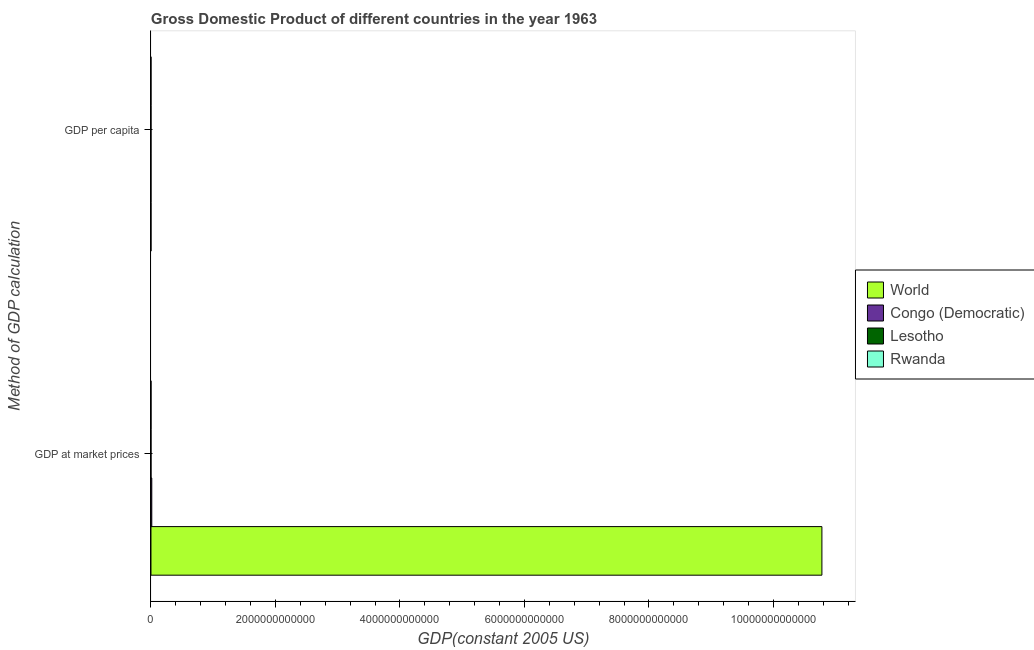Are the number of bars per tick equal to the number of legend labels?
Give a very brief answer. Yes. Are the number of bars on each tick of the Y-axis equal?
Make the answer very short. Yes. How many bars are there on the 2nd tick from the bottom?
Your response must be concise. 4. What is the label of the 1st group of bars from the top?
Ensure brevity in your answer.  GDP per capita. What is the gdp per capita in Rwanda?
Provide a succinct answer. 200.73. Across all countries, what is the maximum gdp per capita?
Ensure brevity in your answer.  3374.82. Across all countries, what is the minimum gdp per capita?
Make the answer very short. 200.73. In which country was the gdp per capita minimum?
Give a very brief answer. Rwanda. What is the total gdp per capita in the graph?
Provide a succinct answer. 4613.54. What is the difference between the gdp per capita in Congo (Democratic) and that in Rwanda?
Ensure brevity in your answer.  594.16. What is the difference between the gdp per capita in Rwanda and the gdp at market prices in Lesotho?
Your response must be concise. -2.18e+08. What is the average gdp per capita per country?
Provide a succinct answer. 1153.39. What is the difference between the gdp per capita and gdp at market prices in Lesotho?
Offer a terse response. -2.18e+08. In how many countries, is the gdp at market prices greater than 8000000000000 US$?
Your answer should be very brief. 1. What is the ratio of the gdp at market prices in Congo (Democratic) to that in Rwanda?
Make the answer very short. 21.01. Is the gdp at market prices in Lesotho less than that in Rwanda?
Offer a terse response. Yes. What does the 1st bar from the top in GDP at market prices represents?
Offer a very short reply. Rwanda. What does the 2nd bar from the bottom in GDP per capita represents?
Offer a very short reply. Congo (Democratic). How many countries are there in the graph?
Ensure brevity in your answer.  4. What is the difference between two consecutive major ticks on the X-axis?
Offer a very short reply. 2.00e+12. Are the values on the major ticks of X-axis written in scientific E-notation?
Your answer should be very brief. No. Does the graph contain grids?
Keep it short and to the point. No. Where does the legend appear in the graph?
Your answer should be compact. Center right. How many legend labels are there?
Keep it short and to the point. 4. What is the title of the graph?
Offer a very short reply. Gross Domestic Product of different countries in the year 1963. What is the label or title of the X-axis?
Your answer should be very brief. GDP(constant 2005 US). What is the label or title of the Y-axis?
Ensure brevity in your answer.  Method of GDP calculation. What is the GDP(constant 2005 US) of World in GDP at market prices?
Your answer should be compact. 1.08e+13. What is the GDP(constant 2005 US) of Congo (Democratic) in GDP at market prices?
Offer a terse response. 1.31e+1. What is the GDP(constant 2005 US) of Lesotho in GDP at market prices?
Keep it short and to the point. 2.18e+08. What is the GDP(constant 2005 US) of Rwanda in GDP at market prices?
Provide a short and direct response. 6.23e+08. What is the GDP(constant 2005 US) in World in GDP per capita?
Keep it short and to the point. 3374.82. What is the GDP(constant 2005 US) of Congo (Democratic) in GDP per capita?
Provide a short and direct response. 794.9. What is the GDP(constant 2005 US) in Lesotho in GDP per capita?
Keep it short and to the point. 243.1. What is the GDP(constant 2005 US) of Rwanda in GDP per capita?
Ensure brevity in your answer.  200.73. Across all Method of GDP calculation, what is the maximum GDP(constant 2005 US) of World?
Keep it short and to the point. 1.08e+13. Across all Method of GDP calculation, what is the maximum GDP(constant 2005 US) in Congo (Democratic)?
Make the answer very short. 1.31e+1. Across all Method of GDP calculation, what is the maximum GDP(constant 2005 US) in Lesotho?
Your response must be concise. 2.18e+08. Across all Method of GDP calculation, what is the maximum GDP(constant 2005 US) in Rwanda?
Your answer should be very brief. 6.23e+08. Across all Method of GDP calculation, what is the minimum GDP(constant 2005 US) in World?
Ensure brevity in your answer.  3374.82. Across all Method of GDP calculation, what is the minimum GDP(constant 2005 US) in Congo (Democratic)?
Give a very brief answer. 794.9. Across all Method of GDP calculation, what is the minimum GDP(constant 2005 US) in Lesotho?
Your answer should be very brief. 243.1. Across all Method of GDP calculation, what is the minimum GDP(constant 2005 US) in Rwanda?
Your response must be concise. 200.73. What is the total GDP(constant 2005 US) of World in the graph?
Your answer should be compact. 1.08e+13. What is the total GDP(constant 2005 US) of Congo (Democratic) in the graph?
Provide a succinct answer. 1.31e+1. What is the total GDP(constant 2005 US) in Lesotho in the graph?
Your answer should be very brief. 2.18e+08. What is the total GDP(constant 2005 US) in Rwanda in the graph?
Keep it short and to the point. 6.23e+08. What is the difference between the GDP(constant 2005 US) in World in GDP at market prices and that in GDP per capita?
Offer a very short reply. 1.08e+13. What is the difference between the GDP(constant 2005 US) of Congo (Democratic) in GDP at market prices and that in GDP per capita?
Provide a succinct answer. 1.31e+1. What is the difference between the GDP(constant 2005 US) of Lesotho in GDP at market prices and that in GDP per capita?
Ensure brevity in your answer.  2.18e+08. What is the difference between the GDP(constant 2005 US) of Rwanda in GDP at market prices and that in GDP per capita?
Keep it short and to the point. 6.23e+08. What is the difference between the GDP(constant 2005 US) of World in GDP at market prices and the GDP(constant 2005 US) of Congo (Democratic) in GDP per capita?
Your response must be concise. 1.08e+13. What is the difference between the GDP(constant 2005 US) in World in GDP at market prices and the GDP(constant 2005 US) in Lesotho in GDP per capita?
Provide a short and direct response. 1.08e+13. What is the difference between the GDP(constant 2005 US) of World in GDP at market prices and the GDP(constant 2005 US) of Rwanda in GDP per capita?
Your response must be concise. 1.08e+13. What is the difference between the GDP(constant 2005 US) of Congo (Democratic) in GDP at market prices and the GDP(constant 2005 US) of Lesotho in GDP per capita?
Offer a very short reply. 1.31e+1. What is the difference between the GDP(constant 2005 US) of Congo (Democratic) in GDP at market prices and the GDP(constant 2005 US) of Rwanda in GDP per capita?
Your response must be concise. 1.31e+1. What is the difference between the GDP(constant 2005 US) in Lesotho in GDP at market prices and the GDP(constant 2005 US) in Rwanda in GDP per capita?
Offer a terse response. 2.18e+08. What is the average GDP(constant 2005 US) of World per Method of GDP calculation?
Your answer should be compact. 5.39e+12. What is the average GDP(constant 2005 US) in Congo (Democratic) per Method of GDP calculation?
Make the answer very short. 6.54e+09. What is the average GDP(constant 2005 US) in Lesotho per Method of GDP calculation?
Ensure brevity in your answer.  1.09e+08. What is the average GDP(constant 2005 US) of Rwanda per Method of GDP calculation?
Your response must be concise. 3.11e+08. What is the difference between the GDP(constant 2005 US) of World and GDP(constant 2005 US) of Congo (Democratic) in GDP at market prices?
Ensure brevity in your answer.  1.08e+13. What is the difference between the GDP(constant 2005 US) in World and GDP(constant 2005 US) in Lesotho in GDP at market prices?
Offer a very short reply. 1.08e+13. What is the difference between the GDP(constant 2005 US) of World and GDP(constant 2005 US) of Rwanda in GDP at market prices?
Your answer should be compact. 1.08e+13. What is the difference between the GDP(constant 2005 US) of Congo (Democratic) and GDP(constant 2005 US) of Lesotho in GDP at market prices?
Keep it short and to the point. 1.29e+1. What is the difference between the GDP(constant 2005 US) of Congo (Democratic) and GDP(constant 2005 US) of Rwanda in GDP at market prices?
Ensure brevity in your answer.  1.25e+1. What is the difference between the GDP(constant 2005 US) in Lesotho and GDP(constant 2005 US) in Rwanda in GDP at market prices?
Provide a short and direct response. -4.04e+08. What is the difference between the GDP(constant 2005 US) of World and GDP(constant 2005 US) of Congo (Democratic) in GDP per capita?
Make the answer very short. 2579.92. What is the difference between the GDP(constant 2005 US) of World and GDP(constant 2005 US) of Lesotho in GDP per capita?
Make the answer very short. 3131.72. What is the difference between the GDP(constant 2005 US) in World and GDP(constant 2005 US) in Rwanda in GDP per capita?
Make the answer very short. 3174.08. What is the difference between the GDP(constant 2005 US) in Congo (Democratic) and GDP(constant 2005 US) in Lesotho in GDP per capita?
Your response must be concise. 551.8. What is the difference between the GDP(constant 2005 US) of Congo (Democratic) and GDP(constant 2005 US) of Rwanda in GDP per capita?
Offer a very short reply. 594.16. What is the difference between the GDP(constant 2005 US) in Lesotho and GDP(constant 2005 US) in Rwanda in GDP per capita?
Offer a terse response. 42.36. What is the ratio of the GDP(constant 2005 US) of World in GDP at market prices to that in GDP per capita?
Your answer should be compact. 3.19e+09. What is the ratio of the GDP(constant 2005 US) of Congo (Democratic) in GDP at market prices to that in GDP per capita?
Ensure brevity in your answer.  1.65e+07. What is the ratio of the GDP(constant 2005 US) in Lesotho in GDP at market prices to that in GDP per capita?
Your answer should be compact. 8.98e+05. What is the ratio of the GDP(constant 2005 US) of Rwanda in GDP at market prices to that in GDP per capita?
Offer a very short reply. 3.10e+06. What is the difference between the highest and the second highest GDP(constant 2005 US) of World?
Your response must be concise. 1.08e+13. What is the difference between the highest and the second highest GDP(constant 2005 US) of Congo (Democratic)?
Keep it short and to the point. 1.31e+1. What is the difference between the highest and the second highest GDP(constant 2005 US) in Lesotho?
Offer a very short reply. 2.18e+08. What is the difference between the highest and the second highest GDP(constant 2005 US) of Rwanda?
Your answer should be very brief. 6.23e+08. What is the difference between the highest and the lowest GDP(constant 2005 US) of World?
Your answer should be very brief. 1.08e+13. What is the difference between the highest and the lowest GDP(constant 2005 US) in Congo (Democratic)?
Give a very brief answer. 1.31e+1. What is the difference between the highest and the lowest GDP(constant 2005 US) in Lesotho?
Your response must be concise. 2.18e+08. What is the difference between the highest and the lowest GDP(constant 2005 US) of Rwanda?
Your answer should be very brief. 6.23e+08. 